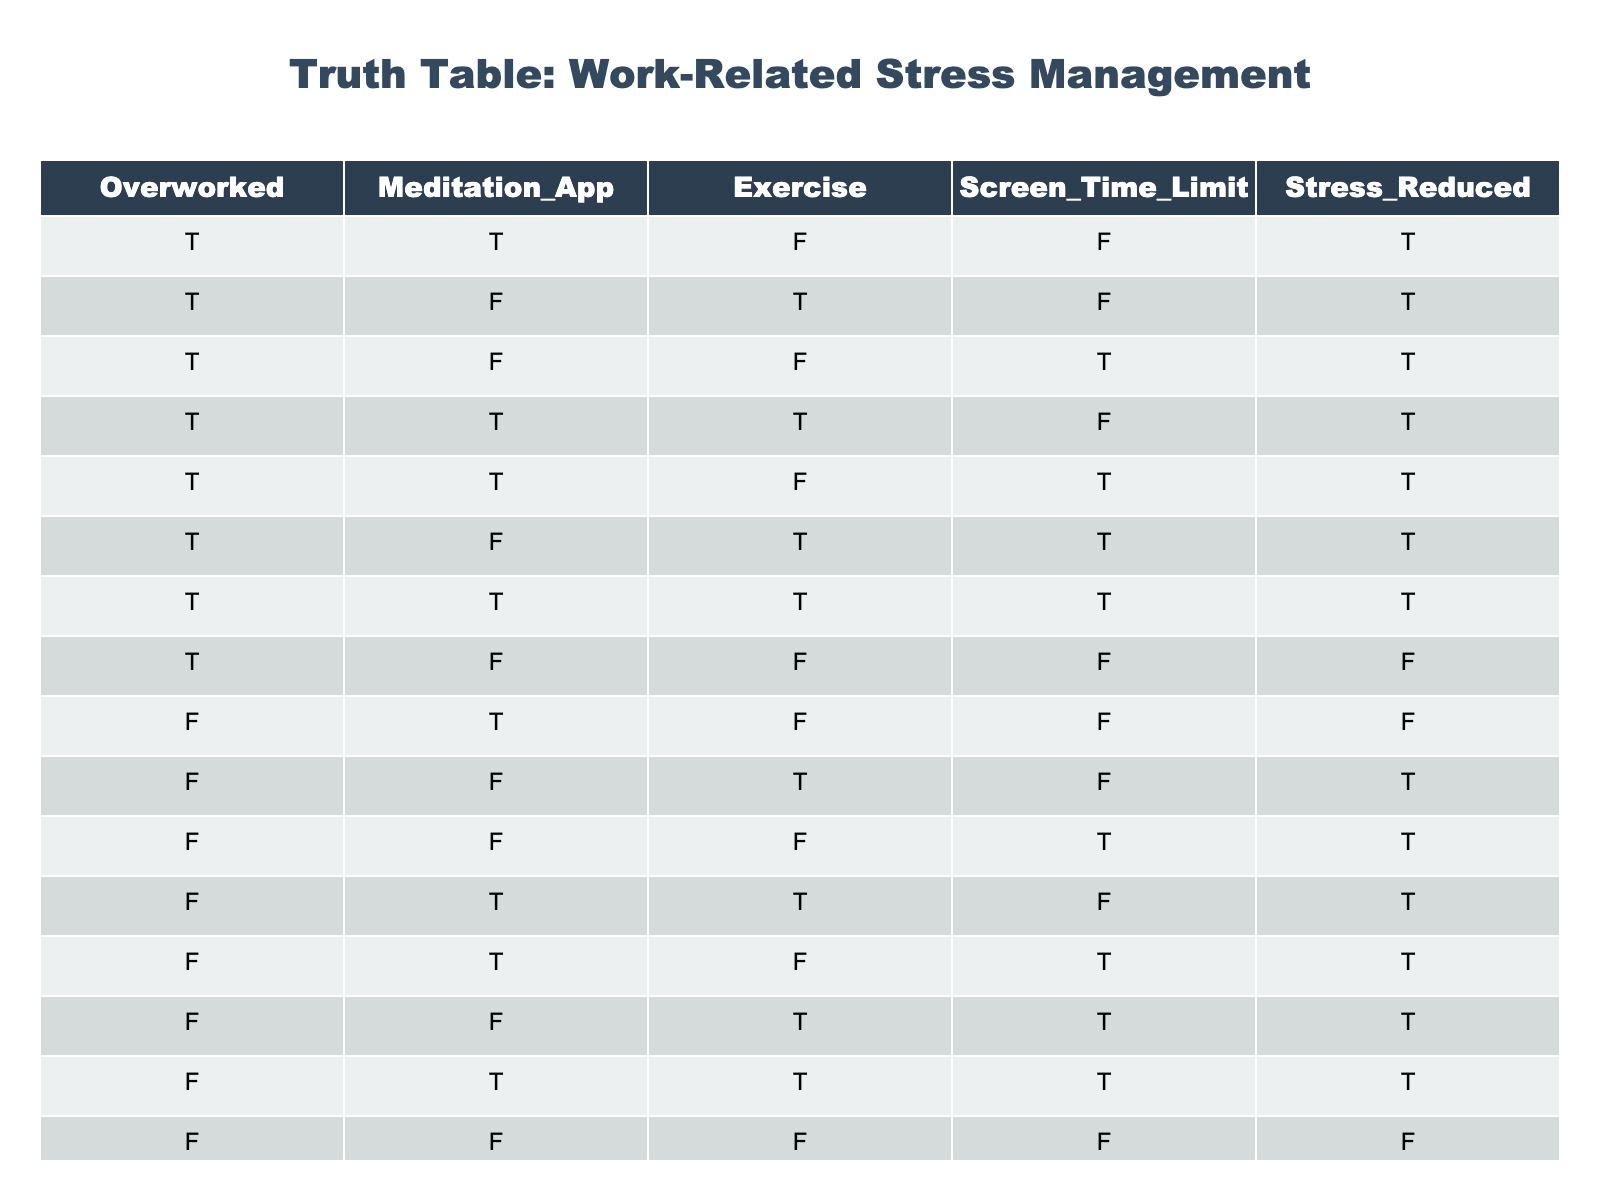What are the conditions that lead to stress reduction? To answer this, we look for rows where "Stress Reduced" is TRUE and check the values in other columns. These conditions are: Overworked = TRUE, Meditation App = TRUE or FALSE, Exercise = TRUE or FALSE, Screen Time Limit = TRUE or FALSE, with the exception of the last row where Overworked is FALSE.
Answer: Overworked + Meditation App + Exercise + Screen Time Limit can all vary, but Overworked must be TRUE How many instances involve Exercise while also reducing stress? We count the occurrences where Exercise is TRUE and Stress Reduced is TRUE. From the table, these rows are: (Overworked, Meditation_App, Exercise, Screen_Time_Limit) = (TRUE, FALSE, TRUE, FALSE), (TRUE, FALSE, TRUE, TRUE), (TRUE, TRUE, TRUE, FALSE), (TRUE, TRUE, TRUE, TRUE), (FALSE, FALSE, TRUE, FALSE), (FALSE, TRUE, TRUE, FALSE), (FALSE, TRUE, TRUE, TRUE). Total occurrences = 7.
Answer: 7 Is stress always reduced when the Meditation App is used? We check every row with Meditation App = TRUE and see if Stress Reduced is still TRUE. There is a row where Meditation App = TRUE, but Stress Reduced = FALSE (in case 9 with Overworked = FALSE). Thus, it is not always true.
Answer: No What is the total number of cases where Overworked is FALSE and Stress Reduced is TRUE? We analyze rows where Overworked is FALSE and count those with Stress Reduced as TRUE. These rows are 5 out of the 7 with Overworked as FALSE (rows 10, 11, 12, 13, 14). Total = 5 instances.
Answer: 5 If someone is Overworked and sets a Screen Time Limit, how often is their stress reduced? We only consider rows where Overworked is TRUE and Screen Time Limit is TRUE. This is seen in the rows where both conditions are true, which are (TRUE, TRUE, FALSE, TRUE) and (TRUE, TRUE, TRUE, TRUE). In both instances, Stress Reduced is TRUE. Total instances = 2, all of which lead to stress being reduced.
Answer: Yes, stress is reduced in 2 instances 